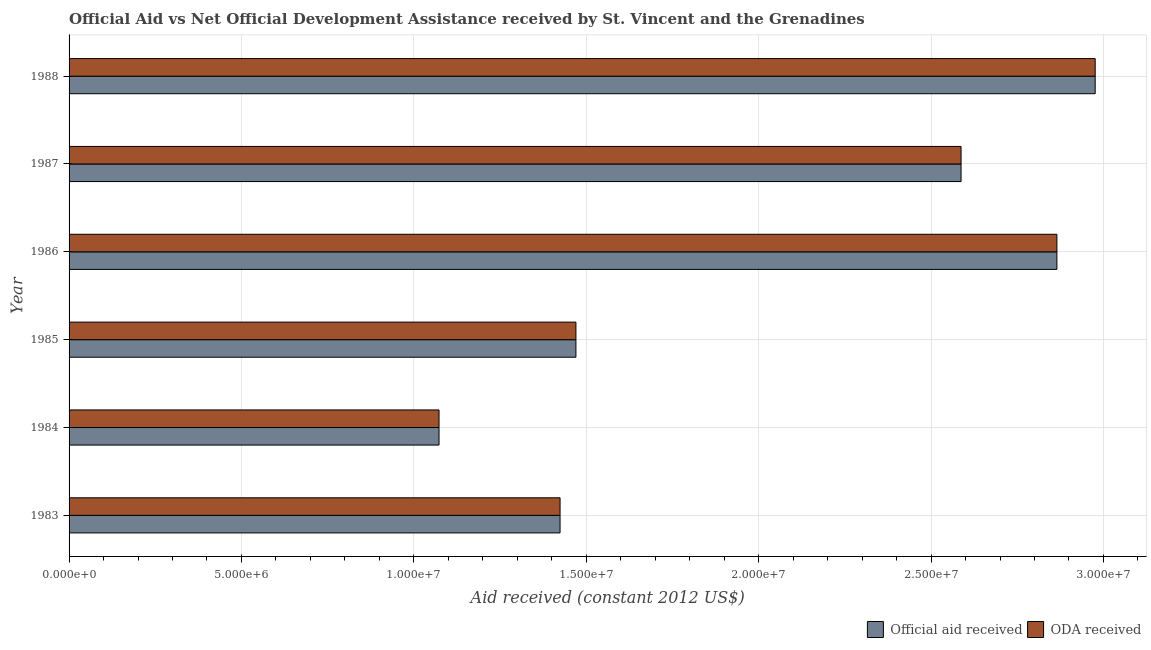How many bars are there on the 4th tick from the top?
Your answer should be compact. 2. What is the oda received in 1986?
Keep it short and to the point. 2.86e+07. Across all years, what is the maximum oda received?
Provide a short and direct response. 2.98e+07. Across all years, what is the minimum oda received?
Offer a very short reply. 1.07e+07. In which year was the official aid received maximum?
Offer a very short reply. 1988. In which year was the official aid received minimum?
Give a very brief answer. 1984. What is the total official aid received in the graph?
Offer a very short reply. 1.24e+08. What is the difference between the oda received in 1983 and that in 1984?
Your answer should be compact. 3.51e+06. What is the difference between the oda received in 1985 and the official aid received in 1984?
Ensure brevity in your answer.  3.97e+06. What is the average official aid received per year?
Make the answer very short. 2.07e+07. In how many years, is the oda received greater than 11000000 US$?
Your answer should be compact. 5. What is the ratio of the oda received in 1987 to that in 1988?
Make the answer very short. 0.87. Is the official aid received in 1984 less than that in 1985?
Provide a short and direct response. Yes. What is the difference between the highest and the second highest official aid received?
Your answer should be compact. 1.11e+06. What is the difference between the highest and the lowest oda received?
Offer a terse response. 1.90e+07. In how many years, is the oda received greater than the average oda received taken over all years?
Make the answer very short. 3. Is the sum of the oda received in 1984 and 1985 greater than the maximum official aid received across all years?
Ensure brevity in your answer.  No. What does the 2nd bar from the top in 1988 represents?
Make the answer very short. Official aid received. What does the 1st bar from the bottom in 1985 represents?
Your answer should be compact. Official aid received. Are all the bars in the graph horizontal?
Offer a very short reply. Yes. How many years are there in the graph?
Offer a very short reply. 6. What is the difference between two consecutive major ticks on the X-axis?
Your answer should be compact. 5.00e+06. Are the values on the major ticks of X-axis written in scientific E-notation?
Your answer should be very brief. Yes. Does the graph contain any zero values?
Your answer should be compact. No. Does the graph contain grids?
Your answer should be very brief. Yes. Where does the legend appear in the graph?
Provide a short and direct response. Bottom right. How many legend labels are there?
Offer a very short reply. 2. What is the title of the graph?
Provide a short and direct response. Official Aid vs Net Official Development Assistance received by St. Vincent and the Grenadines . What is the label or title of the X-axis?
Your answer should be very brief. Aid received (constant 2012 US$). What is the Aid received (constant 2012 US$) in Official aid received in 1983?
Your answer should be compact. 1.42e+07. What is the Aid received (constant 2012 US$) in ODA received in 1983?
Provide a short and direct response. 1.42e+07. What is the Aid received (constant 2012 US$) of Official aid received in 1984?
Offer a very short reply. 1.07e+07. What is the Aid received (constant 2012 US$) of ODA received in 1984?
Provide a short and direct response. 1.07e+07. What is the Aid received (constant 2012 US$) in Official aid received in 1985?
Your response must be concise. 1.47e+07. What is the Aid received (constant 2012 US$) of ODA received in 1985?
Make the answer very short. 1.47e+07. What is the Aid received (constant 2012 US$) of Official aid received in 1986?
Give a very brief answer. 2.86e+07. What is the Aid received (constant 2012 US$) of ODA received in 1986?
Ensure brevity in your answer.  2.86e+07. What is the Aid received (constant 2012 US$) of Official aid received in 1987?
Your answer should be compact. 2.59e+07. What is the Aid received (constant 2012 US$) of ODA received in 1987?
Your response must be concise. 2.59e+07. What is the Aid received (constant 2012 US$) of Official aid received in 1988?
Your answer should be compact. 2.98e+07. What is the Aid received (constant 2012 US$) of ODA received in 1988?
Offer a very short reply. 2.98e+07. Across all years, what is the maximum Aid received (constant 2012 US$) of Official aid received?
Give a very brief answer. 2.98e+07. Across all years, what is the maximum Aid received (constant 2012 US$) in ODA received?
Your response must be concise. 2.98e+07. Across all years, what is the minimum Aid received (constant 2012 US$) in Official aid received?
Give a very brief answer. 1.07e+07. Across all years, what is the minimum Aid received (constant 2012 US$) of ODA received?
Offer a terse response. 1.07e+07. What is the total Aid received (constant 2012 US$) of Official aid received in the graph?
Keep it short and to the point. 1.24e+08. What is the total Aid received (constant 2012 US$) in ODA received in the graph?
Your response must be concise. 1.24e+08. What is the difference between the Aid received (constant 2012 US$) of Official aid received in 1983 and that in 1984?
Ensure brevity in your answer.  3.51e+06. What is the difference between the Aid received (constant 2012 US$) of ODA received in 1983 and that in 1984?
Offer a terse response. 3.51e+06. What is the difference between the Aid received (constant 2012 US$) of Official aid received in 1983 and that in 1985?
Your response must be concise. -4.60e+05. What is the difference between the Aid received (constant 2012 US$) in ODA received in 1983 and that in 1985?
Your answer should be very brief. -4.60e+05. What is the difference between the Aid received (constant 2012 US$) of Official aid received in 1983 and that in 1986?
Offer a very short reply. -1.44e+07. What is the difference between the Aid received (constant 2012 US$) in ODA received in 1983 and that in 1986?
Make the answer very short. -1.44e+07. What is the difference between the Aid received (constant 2012 US$) of Official aid received in 1983 and that in 1987?
Offer a terse response. -1.16e+07. What is the difference between the Aid received (constant 2012 US$) in ODA received in 1983 and that in 1987?
Keep it short and to the point. -1.16e+07. What is the difference between the Aid received (constant 2012 US$) of Official aid received in 1983 and that in 1988?
Make the answer very short. -1.55e+07. What is the difference between the Aid received (constant 2012 US$) of ODA received in 1983 and that in 1988?
Keep it short and to the point. -1.55e+07. What is the difference between the Aid received (constant 2012 US$) of Official aid received in 1984 and that in 1985?
Offer a terse response. -3.97e+06. What is the difference between the Aid received (constant 2012 US$) of ODA received in 1984 and that in 1985?
Offer a very short reply. -3.97e+06. What is the difference between the Aid received (constant 2012 US$) in Official aid received in 1984 and that in 1986?
Keep it short and to the point. -1.79e+07. What is the difference between the Aid received (constant 2012 US$) in ODA received in 1984 and that in 1986?
Ensure brevity in your answer.  -1.79e+07. What is the difference between the Aid received (constant 2012 US$) of Official aid received in 1984 and that in 1987?
Make the answer very short. -1.51e+07. What is the difference between the Aid received (constant 2012 US$) in ODA received in 1984 and that in 1987?
Your answer should be very brief. -1.51e+07. What is the difference between the Aid received (constant 2012 US$) of Official aid received in 1984 and that in 1988?
Your response must be concise. -1.90e+07. What is the difference between the Aid received (constant 2012 US$) of ODA received in 1984 and that in 1988?
Your answer should be very brief. -1.90e+07. What is the difference between the Aid received (constant 2012 US$) in Official aid received in 1985 and that in 1986?
Offer a terse response. -1.40e+07. What is the difference between the Aid received (constant 2012 US$) of ODA received in 1985 and that in 1986?
Ensure brevity in your answer.  -1.40e+07. What is the difference between the Aid received (constant 2012 US$) of Official aid received in 1985 and that in 1987?
Your answer should be compact. -1.12e+07. What is the difference between the Aid received (constant 2012 US$) of ODA received in 1985 and that in 1987?
Provide a succinct answer. -1.12e+07. What is the difference between the Aid received (constant 2012 US$) in Official aid received in 1985 and that in 1988?
Provide a succinct answer. -1.51e+07. What is the difference between the Aid received (constant 2012 US$) of ODA received in 1985 and that in 1988?
Ensure brevity in your answer.  -1.51e+07. What is the difference between the Aid received (constant 2012 US$) of Official aid received in 1986 and that in 1987?
Offer a terse response. 2.78e+06. What is the difference between the Aid received (constant 2012 US$) of ODA received in 1986 and that in 1987?
Keep it short and to the point. 2.78e+06. What is the difference between the Aid received (constant 2012 US$) of Official aid received in 1986 and that in 1988?
Provide a succinct answer. -1.11e+06. What is the difference between the Aid received (constant 2012 US$) in ODA received in 1986 and that in 1988?
Ensure brevity in your answer.  -1.11e+06. What is the difference between the Aid received (constant 2012 US$) of Official aid received in 1987 and that in 1988?
Provide a succinct answer. -3.89e+06. What is the difference between the Aid received (constant 2012 US$) in ODA received in 1987 and that in 1988?
Your answer should be compact. -3.89e+06. What is the difference between the Aid received (constant 2012 US$) of Official aid received in 1983 and the Aid received (constant 2012 US$) of ODA received in 1984?
Your answer should be very brief. 3.51e+06. What is the difference between the Aid received (constant 2012 US$) in Official aid received in 1983 and the Aid received (constant 2012 US$) in ODA received in 1985?
Your answer should be compact. -4.60e+05. What is the difference between the Aid received (constant 2012 US$) in Official aid received in 1983 and the Aid received (constant 2012 US$) in ODA received in 1986?
Offer a terse response. -1.44e+07. What is the difference between the Aid received (constant 2012 US$) in Official aid received in 1983 and the Aid received (constant 2012 US$) in ODA received in 1987?
Ensure brevity in your answer.  -1.16e+07. What is the difference between the Aid received (constant 2012 US$) of Official aid received in 1983 and the Aid received (constant 2012 US$) of ODA received in 1988?
Offer a terse response. -1.55e+07. What is the difference between the Aid received (constant 2012 US$) in Official aid received in 1984 and the Aid received (constant 2012 US$) in ODA received in 1985?
Your answer should be compact. -3.97e+06. What is the difference between the Aid received (constant 2012 US$) in Official aid received in 1984 and the Aid received (constant 2012 US$) in ODA received in 1986?
Provide a succinct answer. -1.79e+07. What is the difference between the Aid received (constant 2012 US$) of Official aid received in 1984 and the Aid received (constant 2012 US$) of ODA received in 1987?
Your response must be concise. -1.51e+07. What is the difference between the Aid received (constant 2012 US$) in Official aid received in 1984 and the Aid received (constant 2012 US$) in ODA received in 1988?
Your answer should be very brief. -1.90e+07. What is the difference between the Aid received (constant 2012 US$) in Official aid received in 1985 and the Aid received (constant 2012 US$) in ODA received in 1986?
Provide a short and direct response. -1.40e+07. What is the difference between the Aid received (constant 2012 US$) in Official aid received in 1985 and the Aid received (constant 2012 US$) in ODA received in 1987?
Give a very brief answer. -1.12e+07. What is the difference between the Aid received (constant 2012 US$) in Official aid received in 1985 and the Aid received (constant 2012 US$) in ODA received in 1988?
Your answer should be very brief. -1.51e+07. What is the difference between the Aid received (constant 2012 US$) in Official aid received in 1986 and the Aid received (constant 2012 US$) in ODA received in 1987?
Your answer should be compact. 2.78e+06. What is the difference between the Aid received (constant 2012 US$) of Official aid received in 1986 and the Aid received (constant 2012 US$) of ODA received in 1988?
Keep it short and to the point. -1.11e+06. What is the difference between the Aid received (constant 2012 US$) in Official aid received in 1987 and the Aid received (constant 2012 US$) in ODA received in 1988?
Keep it short and to the point. -3.89e+06. What is the average Aid received (constant 2012 US$) of Official aid received per year?
Offer a terse response. 2.07e+07. What is the average Aid received (constant 2012 US$) in ODA received per year?
Your answer should be very brief. 2.07e+07. In the year 1983, what is the difference between the Aid received (constant 2012 US$) of Official aid received and Aid received (constant 2012 US$) of ODA received?
Your answer should be very brief. 0. In the year 1985, what is the difference between the Aid received (constant 2012 US$) in Official aid received and Aid received (constant 2012 US$) in ODA received?
Offer a terse response. 0. What is the ratio of the Aid received (constant 2012 US$) of Official aid received in 1983 to that in 1984?
Give a very brief answer. 1.33. What is the ratio of the Aid received (constant 2012 US$) of ODA received in 1983 to that in 1984?
Give a very brief answer. 1.33. What is the ratio of the Aid received (constant 2012 US$) in Official aid received in 1983 to that in 1985?
Keep it short and to the point. 0.97. What is the ratio of the Aid received (constant 2012 US$) in ODA received in 1983 to that in 1985?
Your answer should be compact. 0.97. What is the ratio of the Aid received (constant 2012 US$) of Official aid received in 1983 to that in 1986?
Offer a very short reply. 0.5. What is the ratio of the Aid received (constant 2012 US$) of ODA received in 1983 to that in 1986?
Offer a terse response. 0.5. What is the ratio of the Aid received (constant 2012 US$) in Official aid received in 1983 to that in 1987?
Give a very brief answer. 0.55. What is the ratio of the Aid received (constant 2012 US$) of ODA received in 1983 to that in 1987?
Provide a succinct answer. 0.55. What is the ratio of the Aid received (constant 2012 US$) of Official aid received in 1983 to that in 1988?
Offer a terse response. 0.48. What is the ratio of the Aid received (constant 2012 US$) of ODA received in 1983 to that in 1988?
Keep it short and to the point. 0.48. What is the ratio of the Aid received (constant 2012 US$) in Official aid received in 1984 to that in 1985?
Make the answer very short. 0.73. What is the ratio of the Aid received (constant 2012 US$) of ODA received in 1984 to that in 1985?
Your answer should be compact. 0.73. What is the ratio of the Aid received (constant 2012 US$) in Official aid received in 1984 to that in 1986?
Give a very brief answer. 0.37. What is the ratio of the Aid received (constant 2012 US$) in ODA received in 1984 to that in 1986?
Your answer should be very brief. 0.37. What is the ratio of the Aid received (constant 2012 US$) in Official aid received in 1984 to that in 1987?
Give a very brief answer. 0.41. What is the ratio of the Aid received (constant 2012 US$) in ODA received in 1984 to that in 1987?
Keep it short and to the point. 0.41. What is the ratio of the Aid received (constant 2012 US$) in Official aid received in 1984 to that in 1988?
Your response must be concise. 0.36. What is the ratio of the Aid received (constant 2012 US$) of ODA received in 1984 to that in 1988?
Ensure brevity in your answer.  0.36. What is the ratio of the Aid received (constant 2012 US$) of Official aid received in 1985 to that in 1986?
Your answer should be compact. 0.51. What is the ratio of the Aid received (constant 2012 US$) in ODA received in 1985 to that in 1986?
Offer a terse response. 0.51. What is the ratio of the Aid received (constant 2012 US$) of Official aid received in 1985 to that in 1987?
Your answer should be very brief. 0.57. What is the ratio of the Aid received (constant 2012 US$) of ODA received in 1985 to that in 1987?
Offer a very short reply. 0.57. What is the ratio of the Aid received (constant 2012 US$) in Official aid received in 1985 to that in 1988?
Keep it short and to the point. 0.49. What is the ratio of the Aid received (constant 2012 US$) in ODA received in 1985 to that in 1988?
Ensure brevity in your answer.  0.49. What is the ratio of the Aid received (constant 2012 US$) of Official aid received in 1986 to that in 1987?
Offer a terse response. 1.11. What is the ratio of the Aid received (constant 2012 US$) of ODA received in 1986 to that in 1987?
Give a very brief answer. 1.11. What is the ratio of the Aid received (constant 2012 US$) of Official aid received in 1986 to that in 1988?
Provide a succinct answer. 0.96. What is the ratio of the Aid received (constant 2012 US$) of ODA received in 1986 to that in 1988?
Provide a short and direct response. 0.96. What is the ratio of the Aid received (constant 2012 US$) of Official aid received in 1987 to that in 1988?
Provide a succinct answer. 0.87. What is the ratio of the Aid received (constant 2012 US$) of ODA received in 1987 to that in 1988?
Offer a terse response. 0.87. What is the difference between the highest and the second highest Aid received (constant 2012 US$) of Official aid received?
Your answer should be very brief. 1.11e+06. What is the difference between the highest and the second highest Aid received (constant 2012 US$) of ODA received?
Give a very brief answer. 1.11e+06. What is the difference between the highest and the lowest Aid received (constant 2012 US$) in Official aid received?
Provide a succinct answer. 1.90e+07. What is the difference between the highest and the lowest Aid received (constant 2012 US$) of ODA received?
Your answer should be compact. 1.90e+07. 